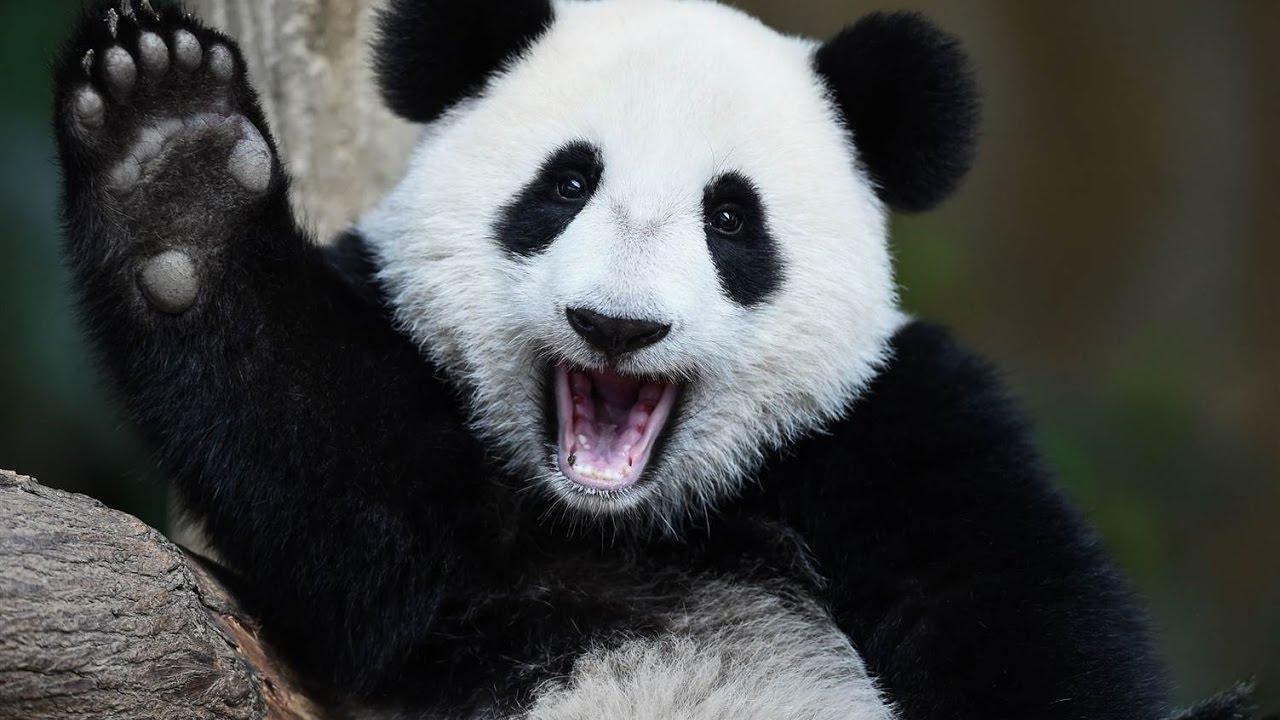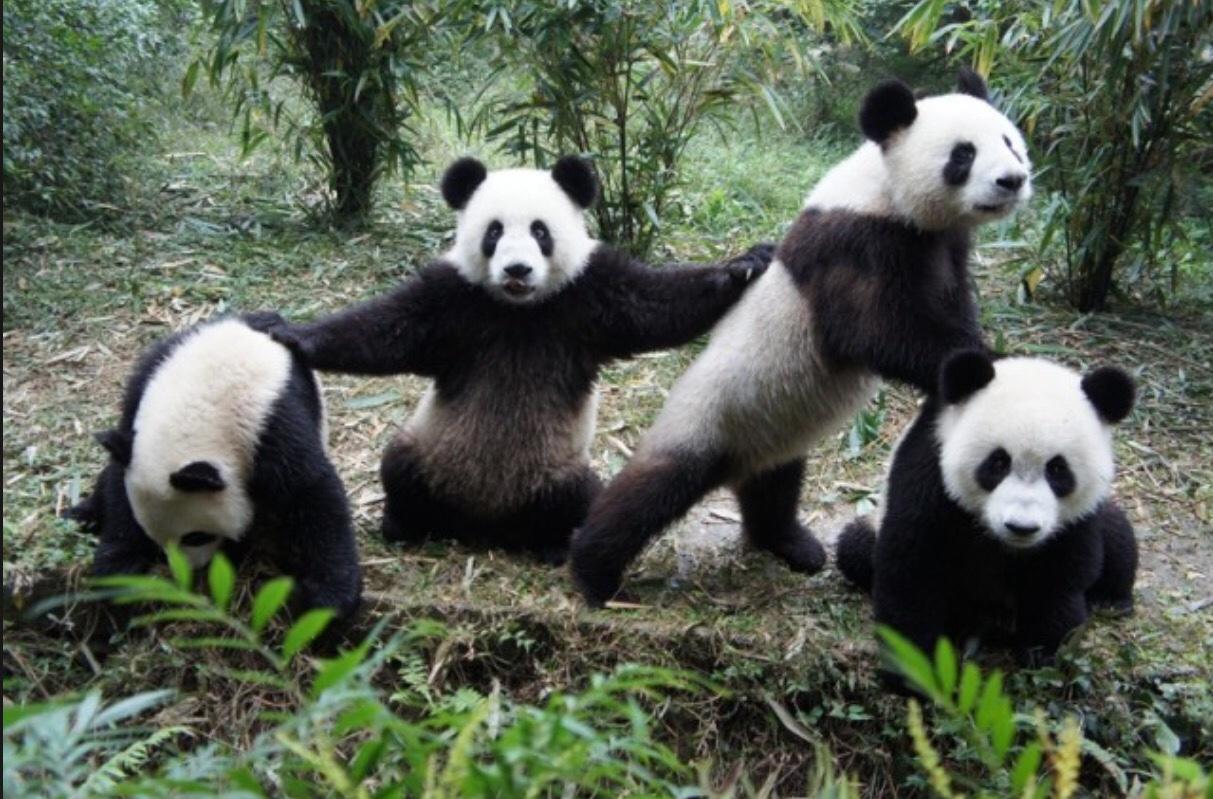The first image is the image on the left, the second image is the image on the right. Assess this claim about the two images: "Two pandas are in a grassy area in the image on the left.". Correct or not? Answer yes or no. No. The first image is the image on the left, the second image is the image on the right. Given the left and right images, does the statement "One image contains twice as many panda bears as the other image." hold true? Answer yes or no. No. 